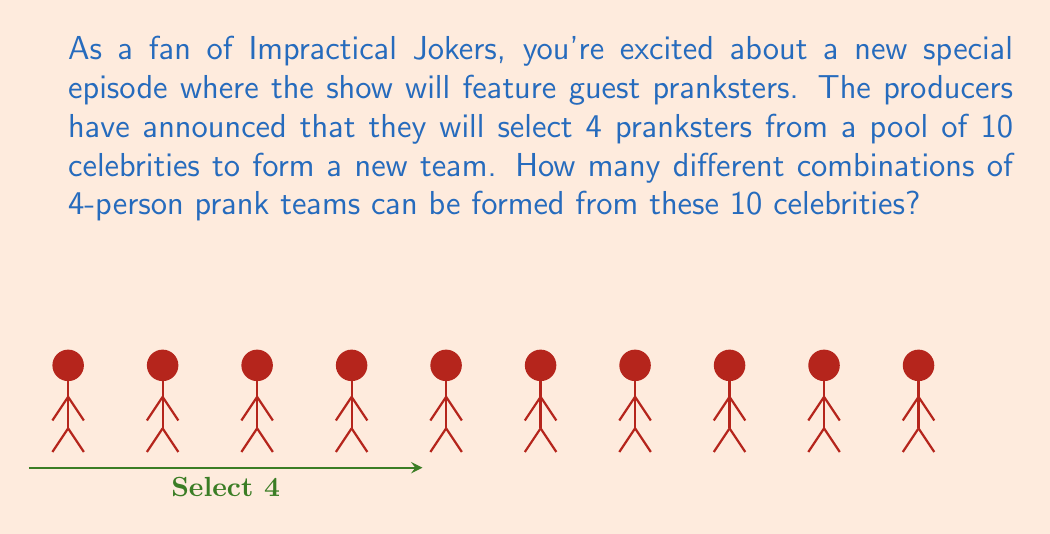Can you answer this question? To solve this problem, we need to use the combination formula. We are selecting 4 people from a group of 10, where the order doesn't matter (it's a team, not a lineup).

The formula for combinations is:

$$C(n,r) = \frac{n!}{r!(n-r)!}$$

Where:
$n$ is the total number of items to choose from (in this case, 10 celebrities)
$r$ is the number of items being chosen (in this case, 4 pranksters)

Let's substitute our values:

$$C(10,4) = \frac{10!}{4!(10-4)!} = \frac{10!}{4!6!}$$

Now, let's calculate this step-by-step:

1) $10! = 10 \times 9 \times 8 \times 7 \times 6!$
2) $4! = 4 \times 3 \times 2 \times 1 = 24$

So our equation becomes:

$$\frac{10 \times 9 \times 8 \times 7 \times 6!}{24 \times 6!}$$

The $6!$ cancels out in the numerator and denominator:

$$\frac{10 \times 9 \times 8 \times 7}{24}$$

Now let's multiply the top and bottom:

$$\frac{5040}{24} = 210$$

Therefore, there are 210 possible combinations of 4-person prank teams that can be formed from the 10 celebrities.
Answer: $210$ 